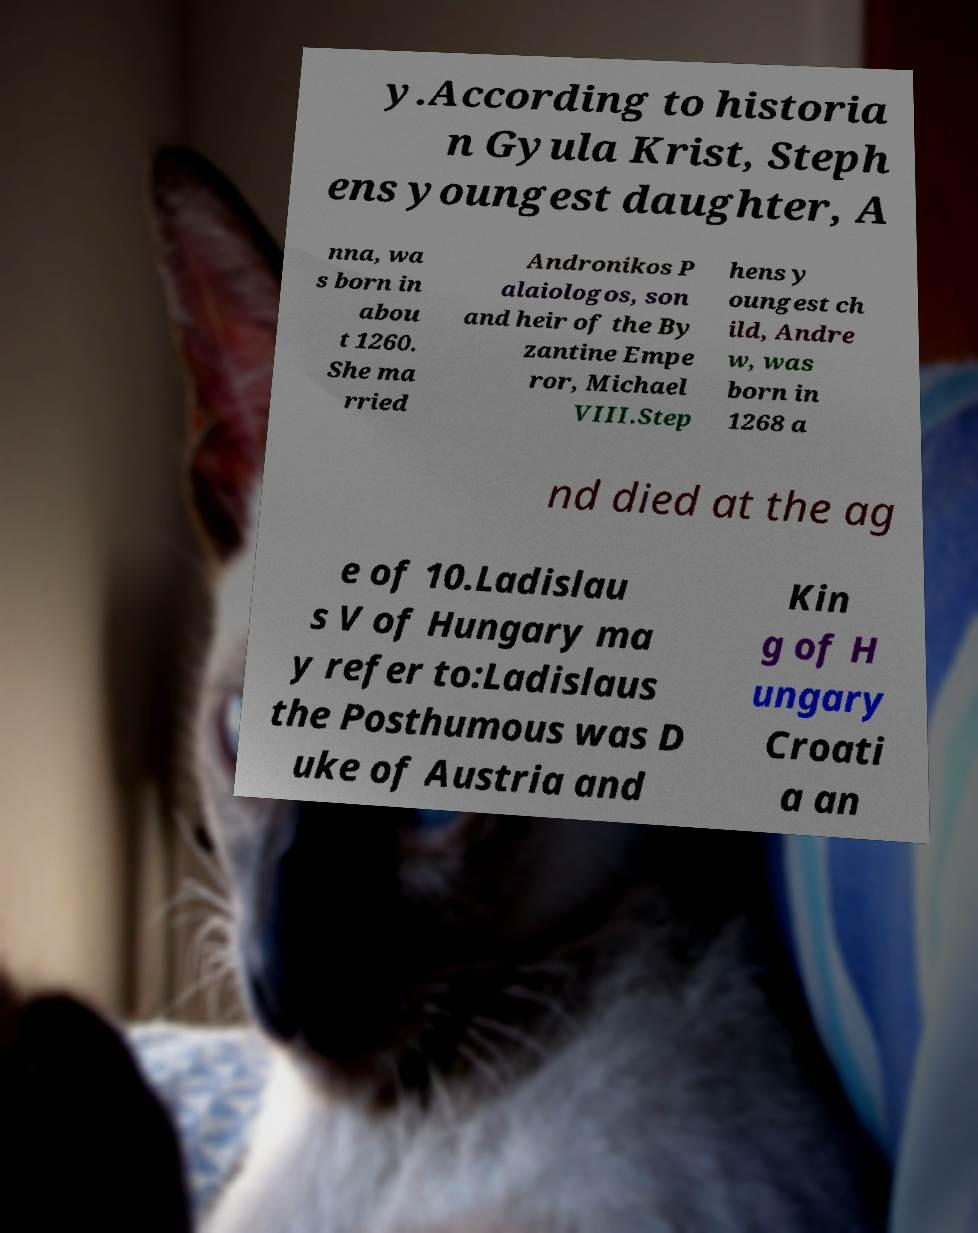Can you accurately transcribe the text from the provided image for me? y.According to historia n Gyula Krist, Steph ens youngest daughter, A nna, wa s born in abou t 1260. She ma rried Andronikos P alaiologos, son and heir of the By zantine Empe ror, Michael VIII.Step hens y oungest ch ild, Andre w, was born in 1268 a nd died at the ag e of 10.Ladislau s V of Hungary ma y refer to:Ladislaus the Posthumous was D uke of Austria and Kin g of H ungary Croati a an 